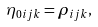Convert formula to latex. <formula><loc_0><loc_0><loc_500><loc_500>\eta _ { 0 i j k } = \rho _ { i j k } ,</formula> 